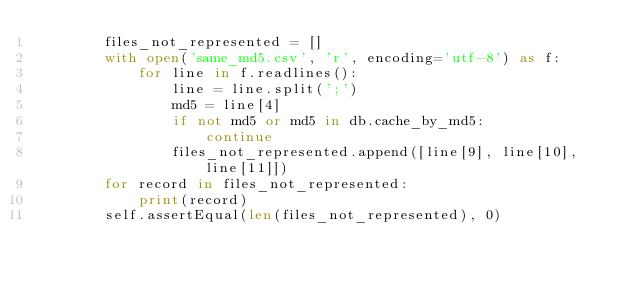<code> <loc_0><loc_0><loc_500><loc_500><_Python_>        files_not_represented = []
        with open('same_md5.csv', 'r', encoding='utf-8') as f:
            for line in f.readlines():
                line = line.split(';')
                md5 = line[4]
                if not md5 or md5 in db.cache_by_md5:
                    continue
                files_not_represented.append([line[9], line[10], line[11]])
        for record in files_not_represented:
            print(record)
        self.assertEqual(len(files_not_represented), 0)

</code> 